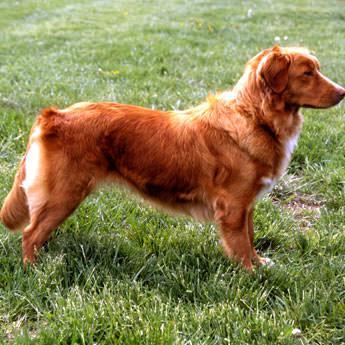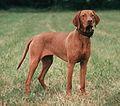The first image is the image on the left, the second image is the image on the right. Examine the images to the left and right. Is the description "The left image contains one dog facing towards the right." accurate? Answer yes or no. Yes. 